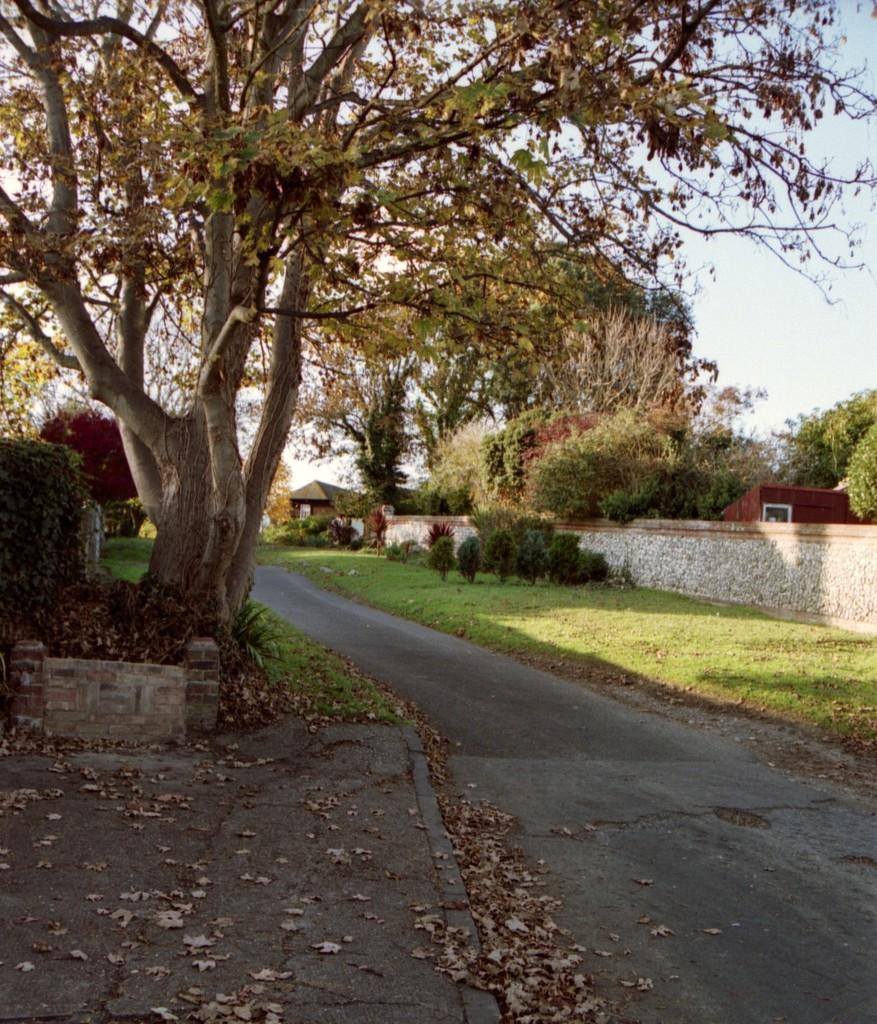What is the main feature in the center of the image? There is a road in the center of the image. What type of vegetation can be seen in the image? There are trees and grass in the image. What is covering the road in the image? Dry leaves are present on the road. What is the taste of the grass in the image? The taste of the grass cannot be determined from the image, as taste is not a visual characteristic. 